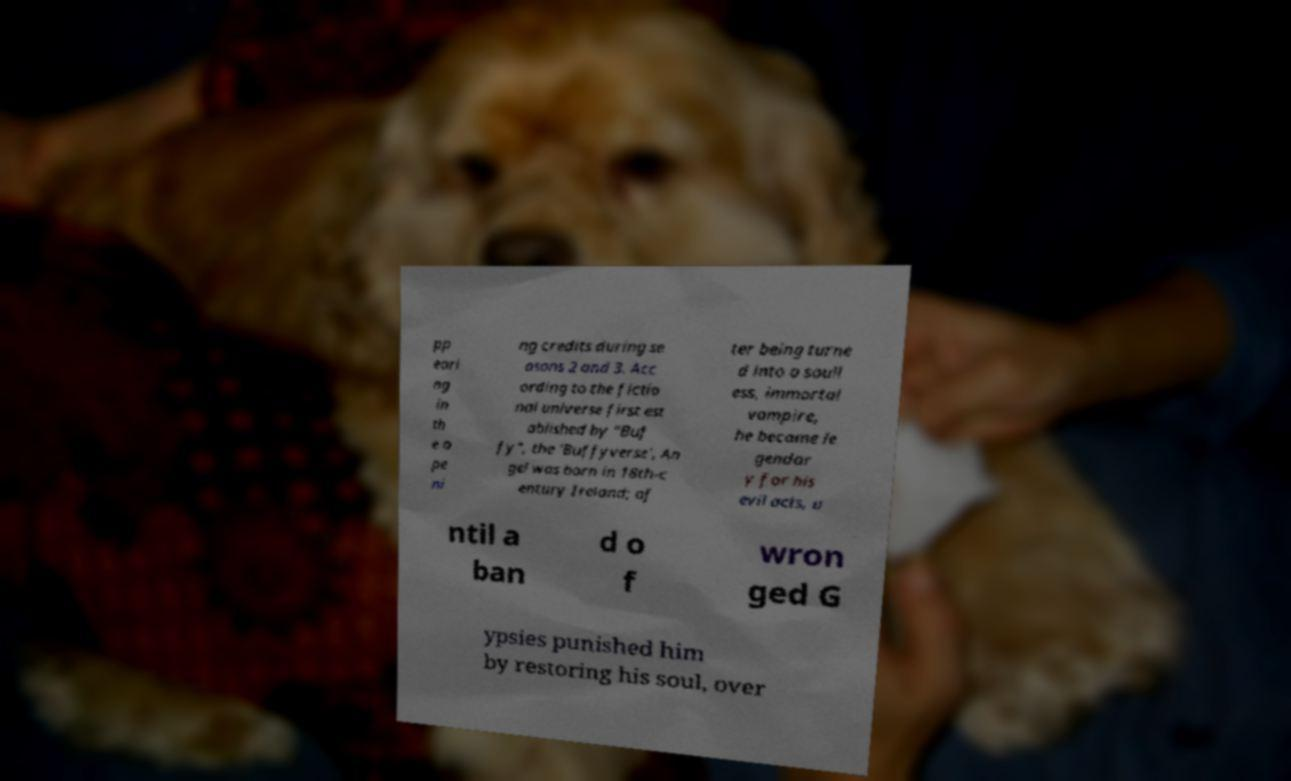Please identify and transcribe the text found in this image. pp eari ng in th e o pe ni ng credits during se asons 2 and 3. Acc ording to the fictio nal universe first est ablished by "Buf fy", the 'Buffyverse', An gel was born in 18th-c entury Ireland; af ter being turne d into a soull ess, immortal vampire, he became le gendar y for his evil acts, u ntil a ban d o f wron ged G ypsies punished him by restoring his soul, over 